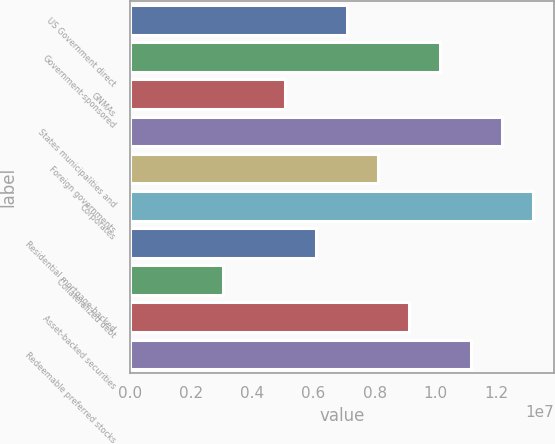<chart> <loc_0><loc_0><loc_500><loc_500><bar_chart><fcel>US Government direct<fcel>Government-sponsored<fcel>GNMAs<fcel>States municipalities and<fcel>Foreign governments<fcel>Corporates<fcel>Residential mortgage-backed<fcel>Collateralized debt<fcel>Asset-backed securities<fcel>Redeemable preferred stocks<nl><fcel>7.10733e+06<fcel>1.01533e+07<fcel>5.07666e+06<fcel>1.2184e+07<fcel>8.12266e+06<fcel>1.31993e+07<fcel>6.092e+06<fcel>3.046e+06<fcel>9.13799e+06<fcel>1.11687e+07<nl></chart> 